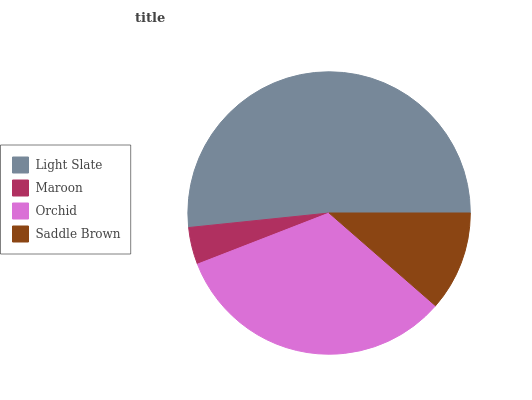Is Maroon the minimum?
Answer yes or no. Yes. Is Light Slate the maximum?
Answer yes or no. Yes. Is Orchid the minimum?
Answer yes or no. No. Is Orchid the maximum?
Answer yes or no. No. Is Orchid greater than Maroon?
Answer yes or no. Yes. Is Maroon less than Orchid?
Answer yes or no. Yes. Is Maroon greater than Orchid?
Answer yes or no. No. Is Orchid less than Maroon?
Answer yes or no. No. Is Orchid the high median?
Answer yes or no. Yes. Is Saddle Brown the low median?
Answer yes or no. Yes. Is Light Slate the high median?
Answer yes or no. No. Is Maroon the low median?
Answer yes or no. No. 